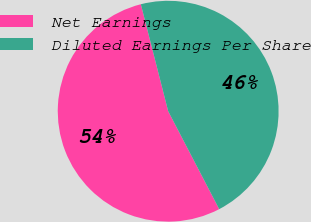Convert chart. <chart><loc_0><loc_0><loc_500><loc_500><pie_chart><fcel>Net Earnings<fcel>Diluted Earnings Per Share<nl><fcel>53.66%<fcel>46.34%<nl></chart> 